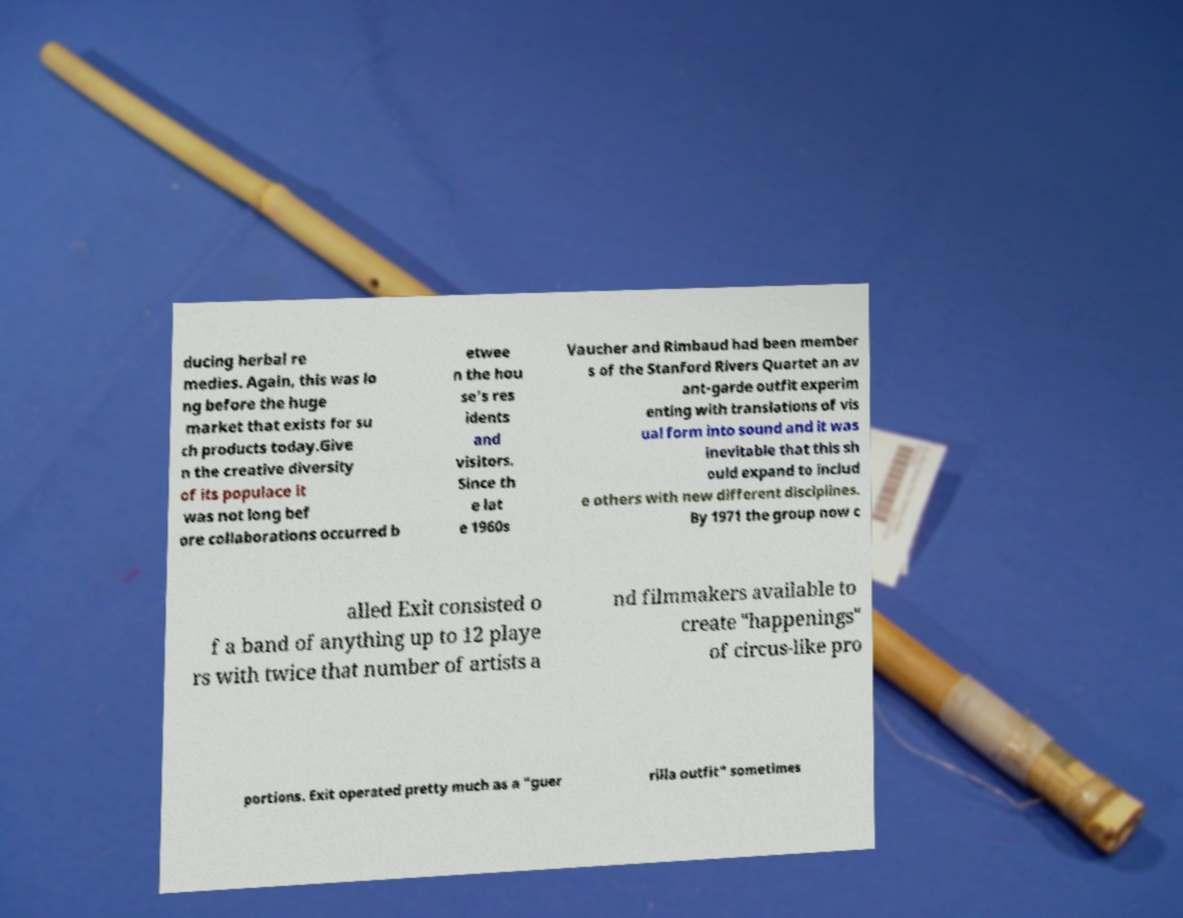There's text embedded in this image that I need extracted. Can you transcribe it verbatim? ducing herbal re medies. Again, this was lo ng before the huge market that exists for su ch products today.Give n the creative diversity of its populace it was not long bef ore collaborations occurred b etwee n the hou se's res idents and visitors. Since th e lat e 1960s Vaucher and Rimbaud had been member s of the Stanford Rivers Quartet an av ant-garde outfit experim enting with translations of vis ual form into sound and it was inevitable that this sh ould expand to includ e others with new different disciplines. By 1971 the group now c alled Exit consisted o f a band of anything up to 12 playe rs with twice that number of artists a nd filmmakers available to create "happenings" of circus-like pro portions. Exit operated pretty much as a "guer rilla outfit" sometimes 